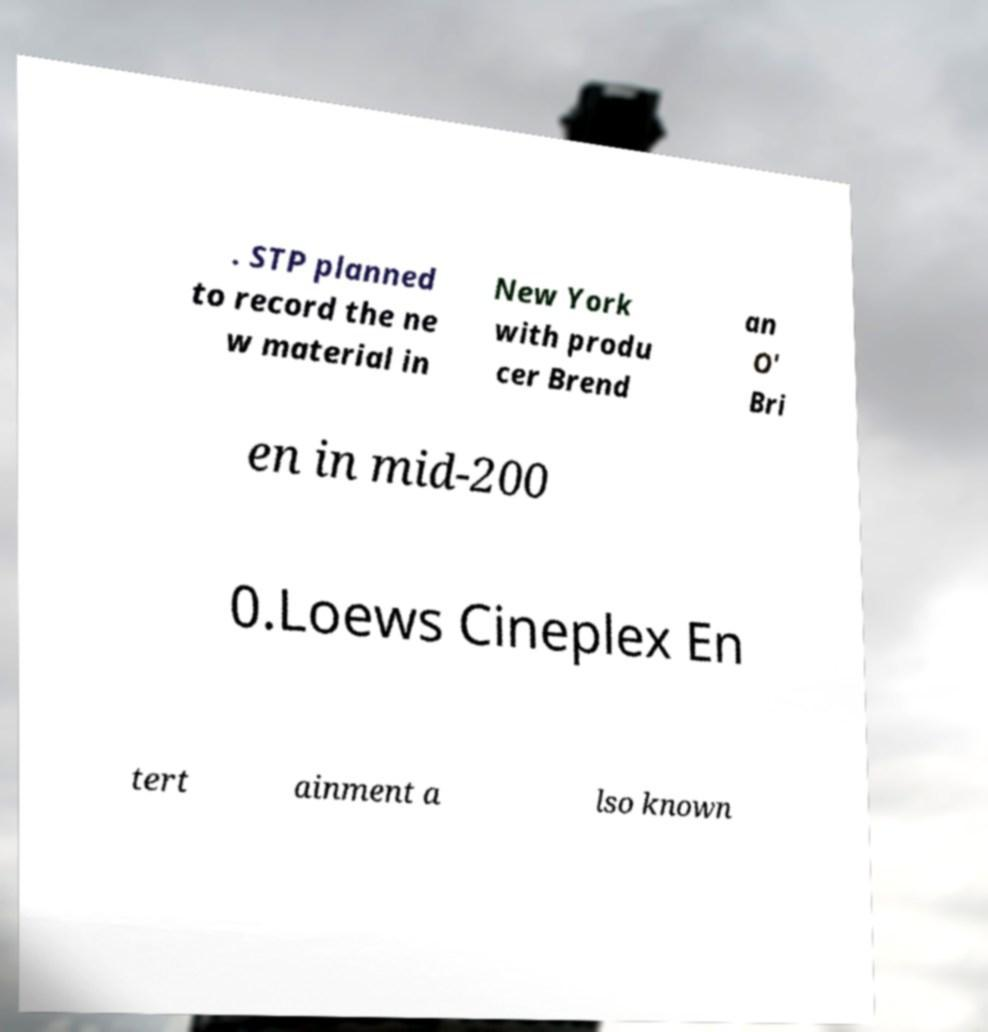What messages or text are displayed in this image? I need them in a readable, typed format. . STP planned to record the ne w material in New York with produ cer Brend an O' Bri en in mid-200 0.Loews Cineplex En tert ainment a lso known 